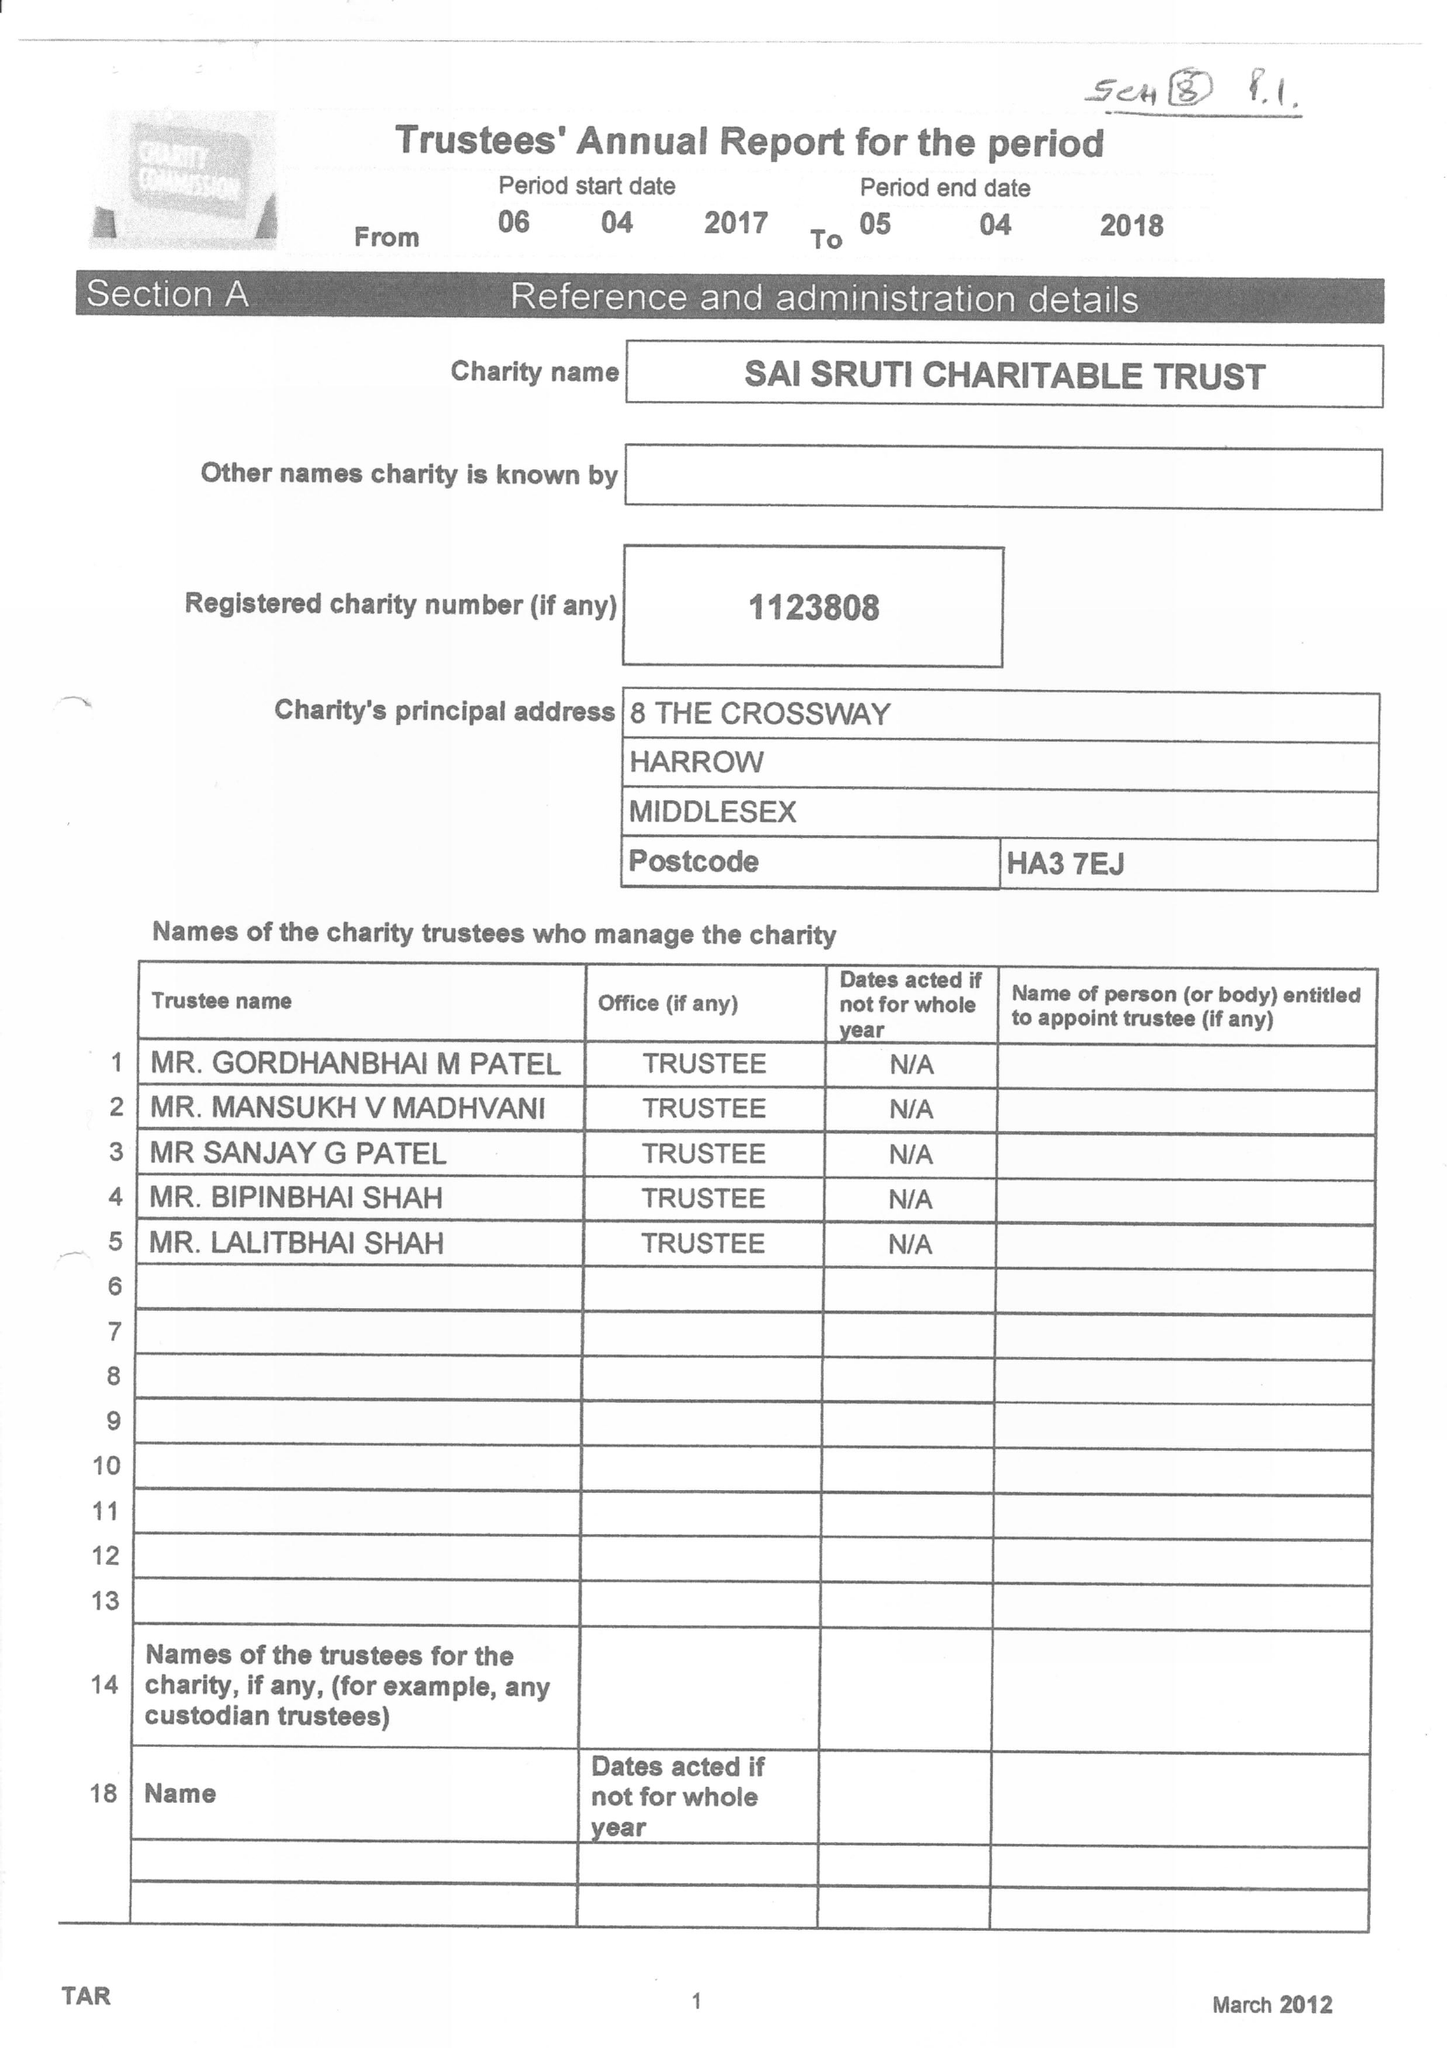What is the value for the address__street_line?
Answer the question using a single word or phrase. 8 THE CROSS WAY 